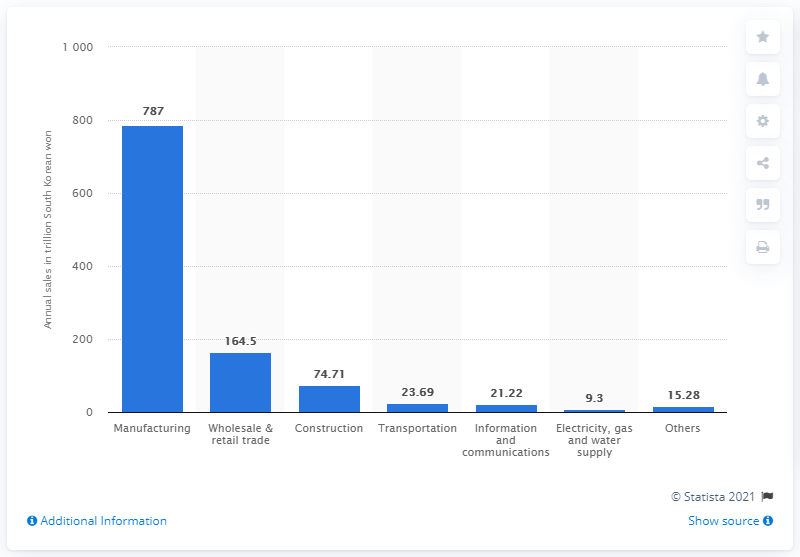List a handful of essential elements in this visual. In 2013, B2B manufacturing e-commerce sales in South Korea were approximately 787 units of South Korean won. 